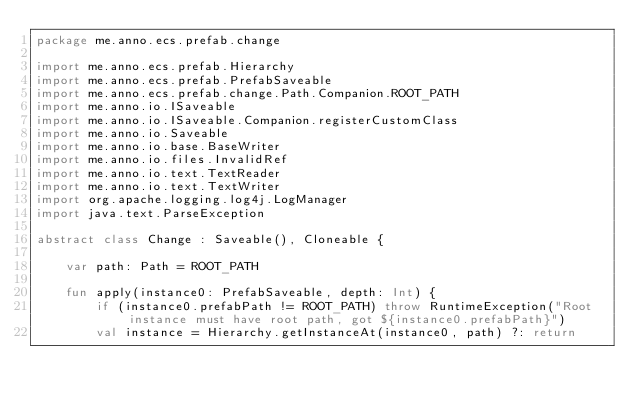<code> <loc_0><loc_0><loc_500><loc_500><_Kotlin_>package me.anno.ecs.prefab.change

import me.anno.ecs.prefab.Hierarchy
import me.anno.ecs.prefab.PrefabSaveable
import me.anno.ecs.prefab.change.Path.Companion.ROOT_PATH
import me.anno.io.ISaveable
import me.anno.io.ISaveable.Companion.registerCustomClass
import me.anno.io.Saveable
import me.anno.io.base.BaseWriter
import me.anno.io.files.InvalidRef
import me.anno.io.text.TextReader
import me.anno.io.text.TextWriter
import org.apache.logging.log4j.LogManager
import java.text.ParseException

abstract class Change : Saveable(), Cloneable {

    var path: Path = ROOT_PATH

    fun apply(instance0: PrefabSaveable, depth: Int) {
        if (instance0.prefabPath != ROOT_PATH) throw RuntimeException("Root instance must have root path, got ${instance0.prefabPath}")
        val instance = Hierarchy.getInstanceAt(instance0, path) ?: return</code> 